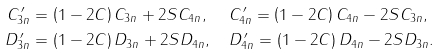Convert formula to latex. <formula><loc_0><loc_0><loc_500><loc_500>C ^ { \, \prime } _ { 3 n } & = \left ( 1 - 2 C \right ) C _ { 3 n } + 2 S C _ { 4 n } , \quad \, C ^ { \, \prime } _ { 4 n } = \left ( 1 - 2 C \right ) C _ { 4 n } - 2 S C _ { 3 n } , \\ D ^ { \, \prime } _ { 3 n } & = \left ( 1 - 2 C \right ) D _ { 3 n } + 2 S D _ { 4 n } , \quad D ^ { \, \prime } _ { 4 n } = \left ( 1 - 2 C \right ) D _ { 4 n } - 2 S D _ { 3 n } .</formula> 